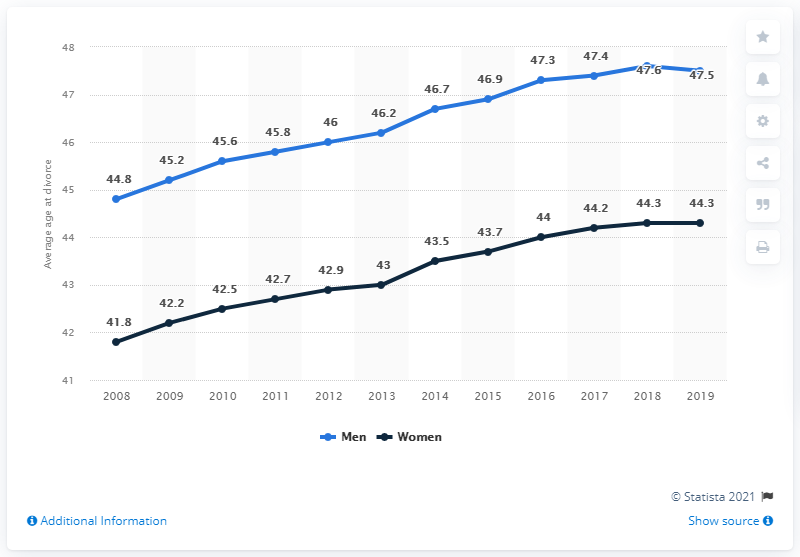Mention a couple of crucial points in this snapshot. From 2008 to 2019, the average age at the time of divorce for men was higher than for women in the Netherlands. According to statistics from 2008 to 2019, women in the Netherlands had the second highest average age at the time of divorce. As of 2008, the average age at divorce for both men and women had increased. 